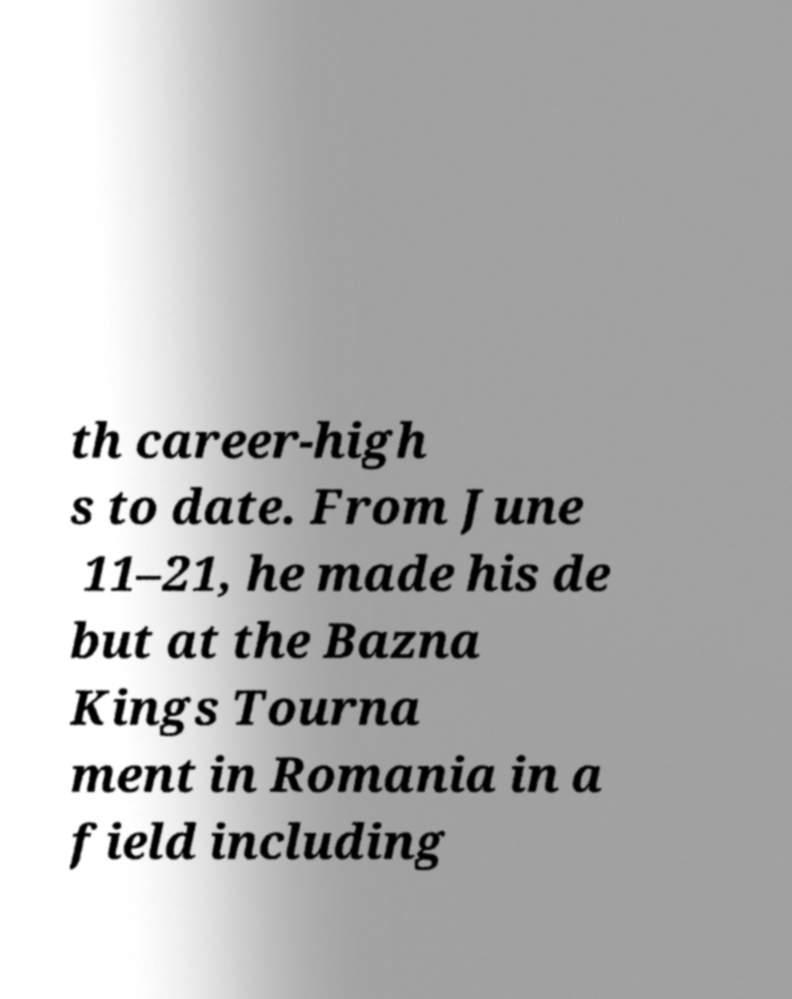Please read and relay the text visible in this image. What does it say? th career-high s to date. From June 11–21, he made his de but at the Bazna Kings Tourna ment in Romania in a field including 